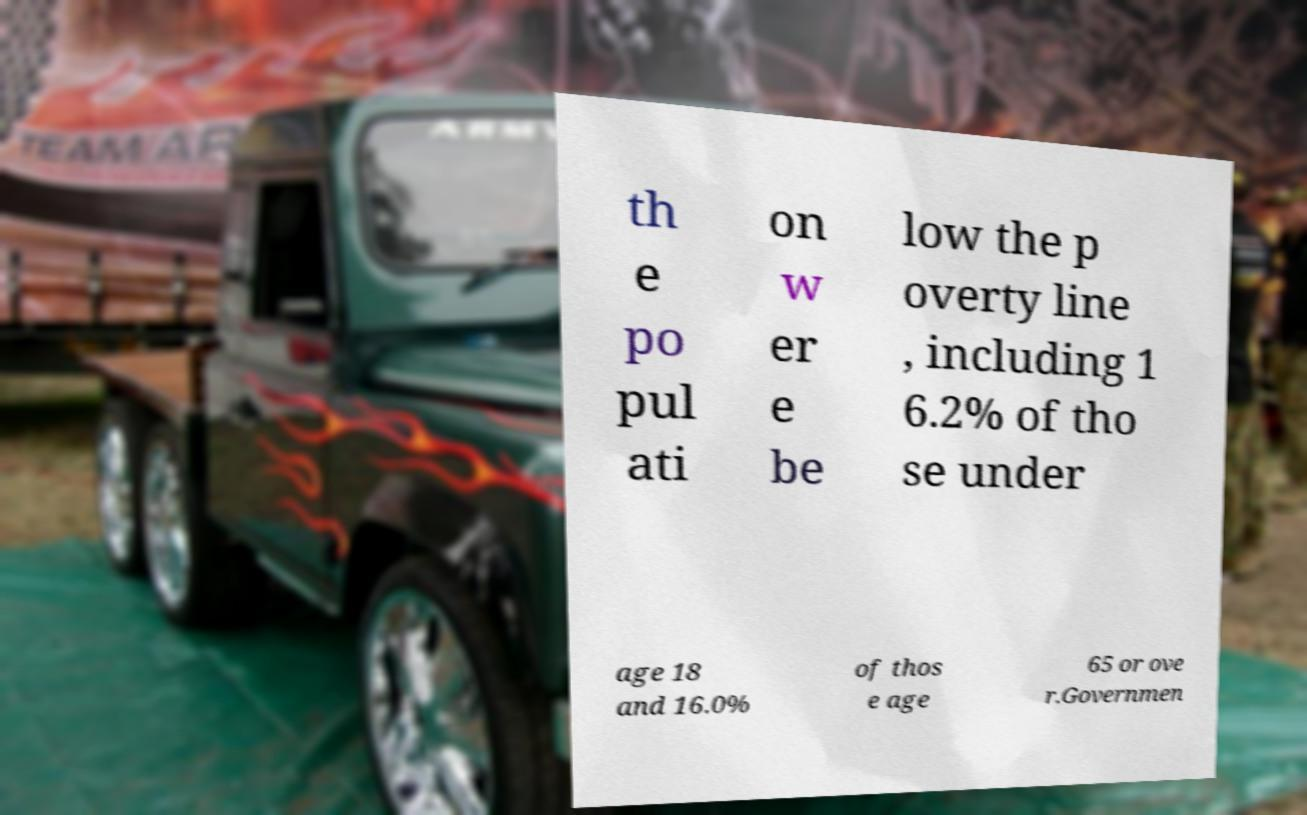Could you extract and type out the text from this image? th e po pul ati on w er e be low the p overty line , including 1 6.2% of tho se under age 18 and 16.0% of thos e age 65 or ove r.Governmen 